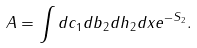Convert formula to latex. <formula><loc_0><loc_0><loc_500><loc_500>A = \int d c _ { 1 } d b _ { 2 } d h _ { 2 } d x e ^ { - S _ { 2 } } .</formula> 